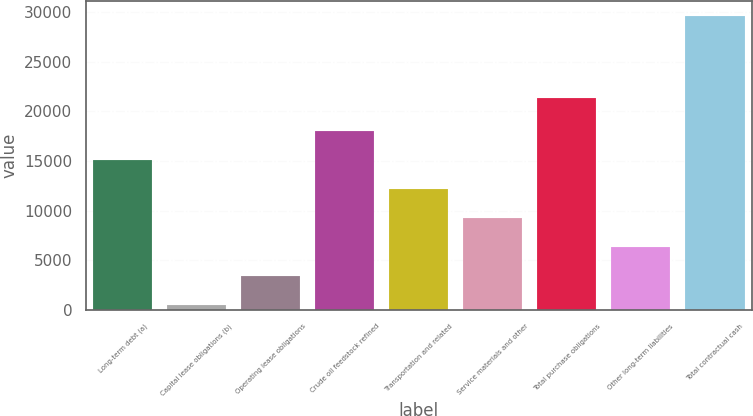Convert chart to OTSL. <chart><loc_0><loc_0><loc_500><loc_500><bar_chart><fcel>Long-term debt (a)<fcel>Capital lease obligations (b)<fcel>Operating lease obligations<fcel>Crude oil feedstock refined<fcel>Transportation and related<fcel>Service materials and other<fcel>Total purchase obligations<fcel>Other long-term liabilities<fcel>Total contractual cash<nl><fcel>15083.5<fcel>516<fcel>3429.5<fcel>17997<fcel>12170<fcel>9256.5<fcel>21302<fcel>6343<fcel>29651<nl></chart> 